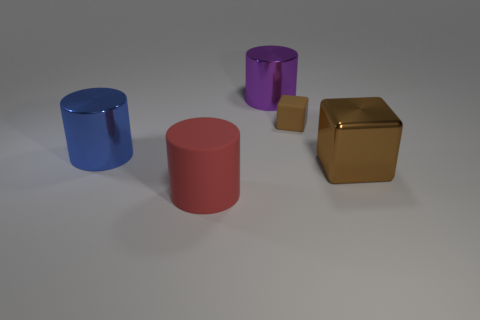What is the shape of the big brown metallic object?
Keep it short and to the point. Cube. The block that is the same color as the small thing is what size?
Your response must be concise. Large. Is the material of the brown cube that is in front of the tiny matte object the same as the large purple object?
Offer a very short reply. Yes. Are there any small cubes of the same color as the small thing?
Your answer should be compact. No. Is the shape of the brown thing behind the big brown shiny cube the same as the big object on the right side of the tiny matte object?
Provide a succinct answer. Yes. Is there another cyan thing that has the same material as the tiny object?
Keep it short and to the point. No. How many purple objects are either tiny objects or big metal things?
Offer a very short reply. 1. How big is the object that is both left of the big purple object and in front of the big blue cylinder?
Provide a succinct answer. Large. Is the number of large rubber cylinders that are in front of the tiny block greater than the number of small things?
Offer a terse response. No. How many cubes are large brown metallic objects or small green metallic objects?
Provide a succinct answer. 1. 